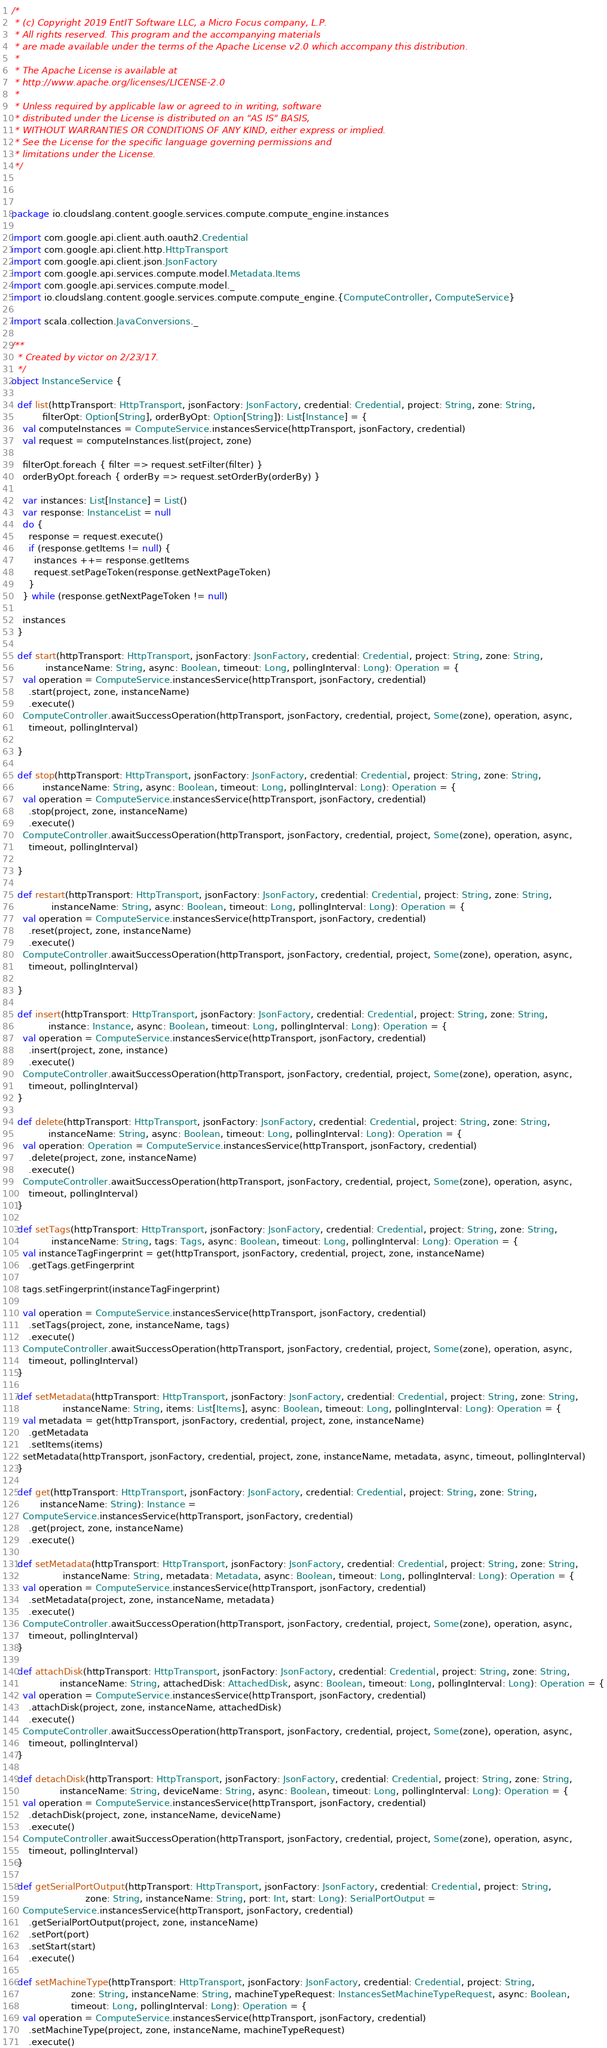<code> <loc_0><loc_0><loc_500><loc_500><_Scala_>/*
 * (c) Copyright 2019 EntIT Software LLC, a Micro Focus company, L.P.
 * All rights reserved. This program and the accompanying materials
 * are made available under the terms of the Apache License v2.0 which accompany this distribution.
 *
 * The Apache License is available at
 * http://www.apache.org/licenses/LICENSE-2.0
 *
 * Unless required by applicable law or agreed to in writing, software
 * distributed under the License is distributed on an "AS IS" BASIS,
 * WITHOUT WARRANTIES OR CONDITIONS OF ANY KIND, either express or implied.
 * See the License for the specific language governing permissions and
 * limitations under the License.
 */



package io.cloudslang.content.google.services.compute.compute_engine.instances

import com.google.api.client.auth.oauth2.Credential
import com.google.api.client.http.HttpTransport
import com.google.api.client.json.JsonFactory
import com.google.api.services.compute.model.Metadata.Items
import com.google.api.services.compute.model._
import io.cloudslang.content.google.services.compute.compute_engine.{ComputeController, ComputeService}

import scala.collection.JavaConversions._

/**
  * Created by victor on 2/23/17.
  */
object InstanceService {

  def list(httpTransport: HttpTransport, jsonFactory: JsonFactory, credential: Credential, project: String, zone: String,
           filterOpt: Option[String], orderByOpt: Option[String]): List[Instance] = {
    val computeInstances = ComputeService.instancesService(httpTransport, jsonFactory, credential)
    val request = computeInstances.list(project, zone)

    filterOpt.foreach { filter => request.setFilter(filter) }
    orderByOpt.foreach { orderBy => request.setOrderBy(orderBy) }

    var instances: List[Instance] = List()
    var response: InstanceList = null
    do {
      response = request.execute()
      if (response.getItems != null) {
        instances ++= response.getItems
        request.setPageToken(response.getNextPageToken)
      }
    } while (response.getNextPageToken != null)

    instances
  }

  def start(httpTransport: HttpTransport, jsonFactory: JsonFactory, credential: Credential, project: String, zone: String,
            instanceName: String, async: Boolean, timeout: Long, pollingInterval: Long): Operation = {
    val operation = ComputeService.instancesService(httpTransport, jsonFactory, credential)
      .start(project, zone, instanceName)
      .execute()
    ComputeController.awaitSuccessOperation(httpTransport, jsonFactory, credential, project, Some(zone), operation, async,
      timeout, pollingInterval)

  }

  def stop(httpTransport: HttpTransport, jsonFactory: JsonFactory, credential: Credential, project: String, zone: String,
           instanceName: String, async: Boolean, timeout: Long, pollingInterval: Long): Operation = {
    val operation = ComputeService.instancesService(httpTransport, jsonFactory, credential)
      .stop(project, zone, instanceName)
      .execute()
    ComputeController.awaitSuccessOperation(httpTransport, jsonFactory, credential, project, Some(zone), operation, async,
      timeout, pollingInterval)

  }

  def restart(httpTransport: HttpTransport, jsonFactory: JsonFactory, credential: Credential, project: String, zone: String,
              instanceName: String, async: Boolean, timeout: Long, pollingInterval: Long): Operation = {
    val operation = ComputeService.instancesService(httpTransport, jsonFactory, credential)
      .reset(project, zone, instanceName)
      .execute()
    ComputeController.awaitSuccessOperation(httpTransport, jsonFactory, credential, project, Some(zone), operation, async,
      timeout, pollingInterval)

  }

  def insert(httpTransport: HttpTransport, jsonFactory: JsonFactory, credential: Credential, project: String, zone: String,
             instance: Instance, async: Boolean, timeout: Long, pollingInterval: Long): Operation = {
    val operation = ComputeService.instancesService(httpTransport, jsonFactory, credential)
      .insert(project, zone, instance)
      .execute()
    ComputeController.awaitSuccessOperation(httpTransport, jsonFactory, credential, project, Some(zone), operation, async,
      timeout, pollingInterval)
  }

  def delete(httpTransport: HttpTransport, jsonFactory: JsonFactory, credential: Credential, project: String, zone: String,
             instanceName: String, async: Boolean, timeout: Long, pollingInterval: Long): Operation = {
    val operation: Operation = ComputeService.instancesService(httpTransport, jsonFactory, credential)
      .delete(project, zone, instanceName)
      .execute()
    ComputeController.awaitSuccessOperation(httpTransport, jsonFactory, credential, project, Some(zone), operation, async,
      timeout, pollingInterval)
  }

  def setTags(httpTransport: HttpTransport, jsonFactory: JsonFactory, credential: Credential, project: String, zone: String,
              instanceName: String, tags: Tags, async: Boolean, timeout: Long, pollingInterval: Long): Operation = {
    val instanceTagFingerprint = get(httpTransport, jsonFactory, credential, project, zone, instanceName)
      .getTags.getFingerprint

    tags.setFingerprint(instanceTagFingerprint)

    val operation = ComputeService.instancesService(httpTransport, jsonFactory, credential)
      .setTags(project, zone, instanceName, tags)
      .execute()
    ComputeController.awaitSuccessOperation(httpTransport, jsonFactory, credential, project, Some(zone), operation, async,
      timeout, pollingInterval)
  }

  def setMetadata(httpTransport: HttpTransport, jsonFactory: JsonFactory, credential: Credential, project: String, zone: String,
                  instanceName: String, items: List[Items], async: Boolean, timeout: Long, pollingInterval: Long): Operation = {
    val metadata = get(httpTransport, jsonFactory, credential, project, zone, instanceName)
      .getMetadata
      .setItems(items)
    setMetadata(httpTransport, jsonFactory, credential, project, zone, instanceName, metadata, async, timeout, pollingInterval)
  }

  def get(httpTransport: HttpTransport, jsonFactory: JsonFactory, credential: Credential, project: String, zone: String,
          instanceName: String): Instance =
    ComputeService.instancesService(httpTransport, jsonFactory, credential)
      .get(project, zone, instanceName)
      .execute()

  def setMetadata(httpTransport: HttpTransport, jsonFactory: JsonFactory, credential: Credential, project: String, zone: String,
                  instanceName: String, metadata: Metadata, async: Boolean, timeout: Long, pollingInterval: Long): Operation = {
    val operation = ComputeService.instancesService(httpTransport, jsonFactory, credential)
      .setMetadata(project, zone, instanceName, metadata)
      .execute()
    ComputeController.awaitSuccessOperation(httpTransport, jsonFactory, credential, project, Some(zone), operation, async,
      timeout, pollingInterval)
  }

  def attachDisk(httpTransport: HttpTransport, jsonFactory: JsonFactory, credential: Credential, project: String, zone: String,
                 instanceName: String, attachedDisk: AttachedDisk, async: Boolean, timeout: Long, pollingInterval: Long): Operation = {
    val operation = ComputeService.instancesService(httpTransport, jsonFactory, credential)
      .attachDisk(project, zone, instanceName, attachedDisk)
      .execute()
    ComputeController.awaitSuccessOperation(httpTransport, jsonFactory, credential, project, Some(zone), operation, async,
      timeout, pollingInterval)
  }

  def detachDisk(httpTransport: HttpTransport, jsonFactory: JsonFactory, credential: Credential, project: String, zone: String,
                 instanceName: String, deviceName: String, async: Boolean, timeout: Long, pollingInterval: Long): Operation = {
    val operation = ComputeService.instancesService(httpTransport, jsonFactory, credential)
      .detachDisk(project, zone, instanceName, deviceName)
      .execute()
    ComputeController.awaitSuccessOperation(httpTransport, jsonFactory, credential, project, Some(zone), operation, async,
      timeout, pollingInterval)
  }

  def getSerialPortOutput(httpTransport: HttpTransport, jsonFactory: JsonFactory, credential: Credential, project: String,
                          zone: String, instanceName: String, port: Int, start: Long): SerialPortOutput =
    ComputeService.instancesService(httpTransport, jsonFactory, credential)
      .getSerialPortOutput(project, zone, instanceName)
      .setPort(port)
      .setStart(start)
      .execute()

  def setMachineType(httpTransport: HttpTransport, jsonFactory: JsonFactory, credential: Credential, project: String,
                     zone: String, instanceName: String, machineTypeRequest: InstancesSetMachineTypeRequest, async: Boolean,
                     timeout: Long, pollingInterval: Long): Operation = {
    val operation = ComputeService.instancesService(httpTransport, jsonFactory, credential)
      .setMachineType(project, zone, instanceName, machineTypeRequest)
      .execute()</code> 